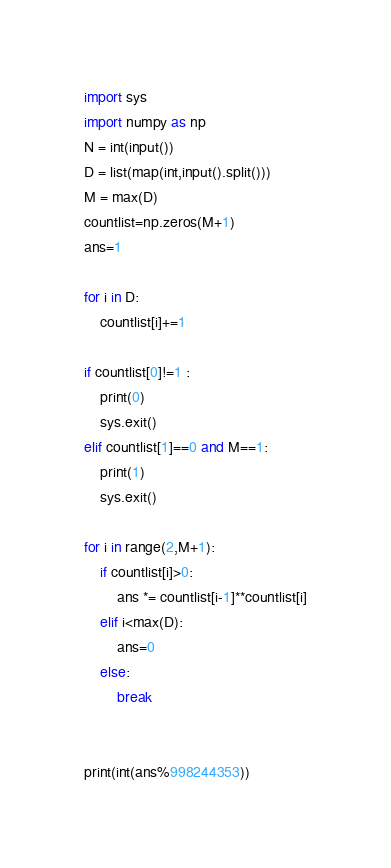Convert code to text. <code><loc_0><loc_0><loc_500><loc_500><_Python_>import sys
import numpy as np
N = int(input())
D = list(map(int,input().split()))
M = max(D)
countlist=np.zeros(M+1)
ans=1

for i in D:
    countlist[i]+=1

if countlist[0]!=1 :
    print(0)
    sys.exit()
elif countlist[1]==0 and M==1:
    print(1)
    sys.exit()

for i in range(2,M+1):
    if countlist[i]>0:
        ans *= countlist[i-1]**countlist[i]
    elif i<max(D):
        ans=0
    else:
        break


print(int(ans%998244353)) </code> 